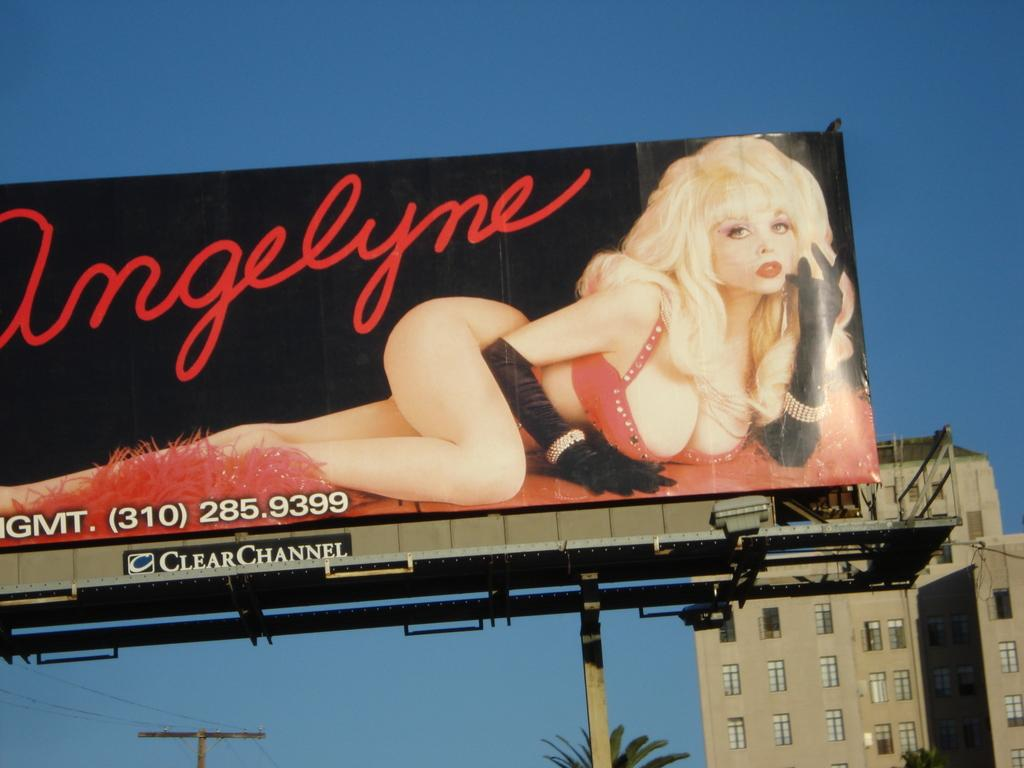<image>
Render a clear and concise summary of the photo. the word angelyne that is on a sign 